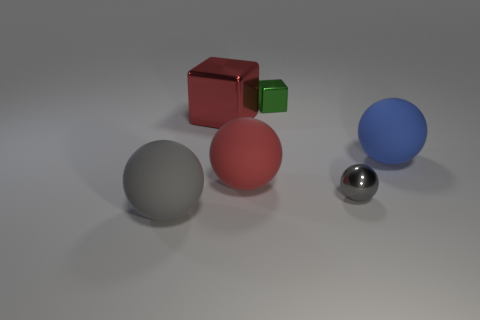Is there a big rubber object of the same color as the large metal thing?
Offer a terse response. Yes. The small object that is in front of the big red metal object to the left of the gray metallic object is what color?
Offer a very short reply. Gray. There is a shiny thing that is in front of the ball that is on the right side of the gray sphere right of the gray matte thing; what size is it?
Keep it short and to the point. Small. Is the large blue object made of the same material as the gray thing to the left of the gray metal thing?
Provide a succinct answer. Yes. What size is the red ball that is made of the same material as the big gray object?
Give a very brief answer. Large. Is there a gray thing that has the same shape as the blue matte object?
Give a very brief answer. Yes. How many objects are either gray spheres that are in front of the small gray sphere or red matte things?
Ensure brevity in your answer.  2. The rubber ball that is the same color as the metal ball is what size?
Give a very brief answer. Large. There is a shiny thing to the right of the tiny block; is its color the same as the large object to the left of the red shiny object?
Give a very brief answer. Yes. The green metallic thing has what size?
Provide a short and direct response. Small. 